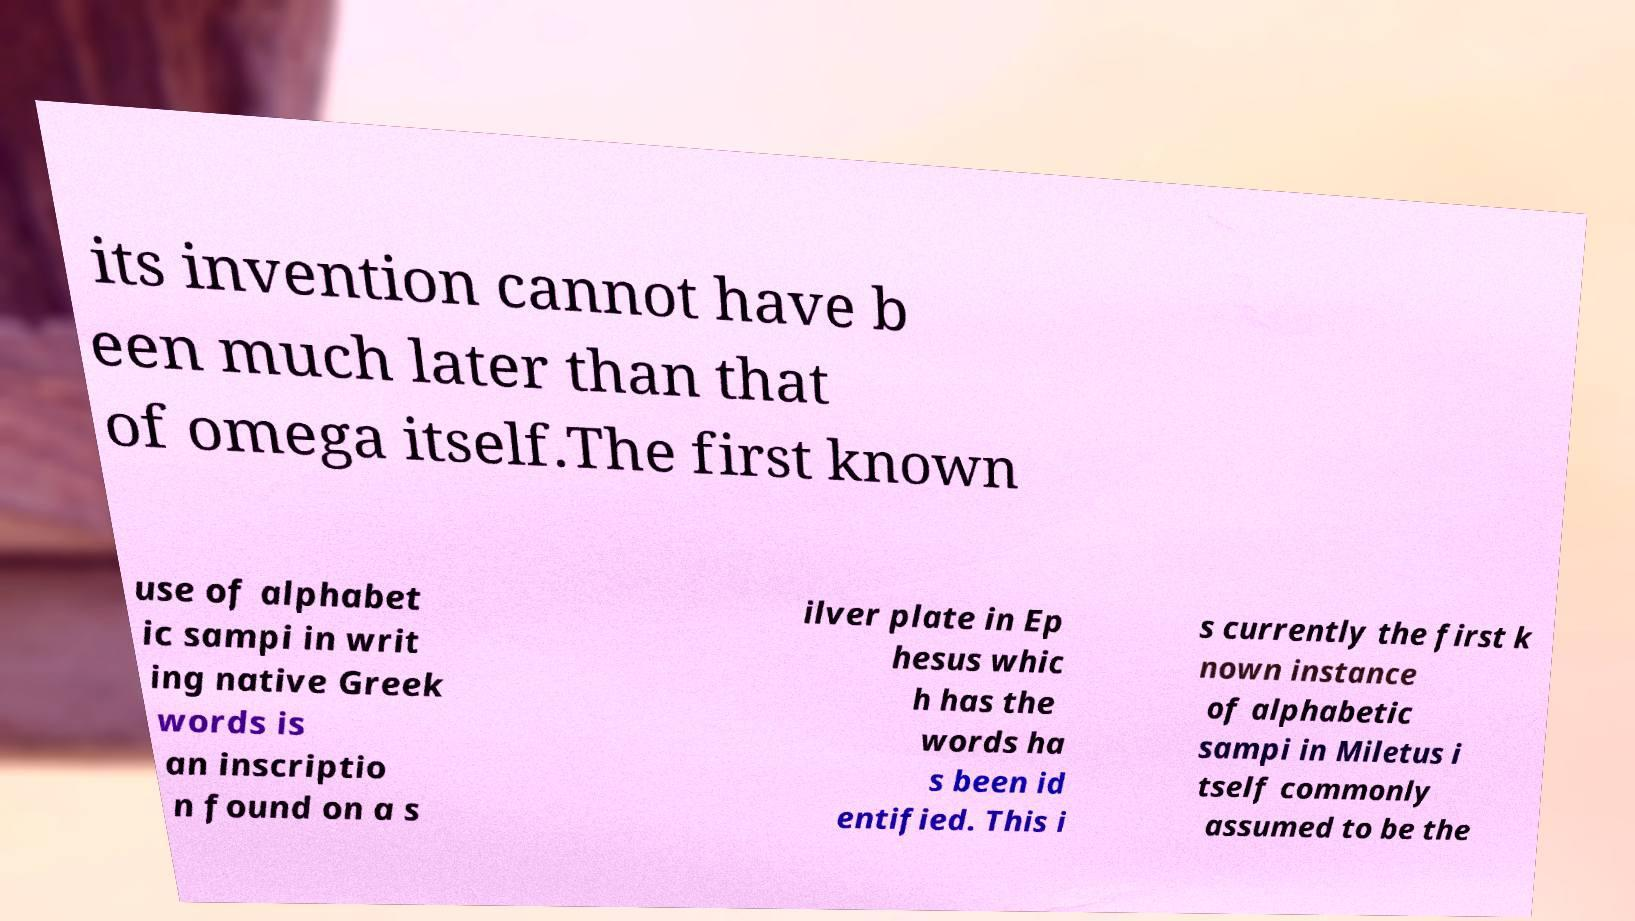Could you extract and type out the text from this image? its invention cannot have b een much later than that of omega itself.The first known use of alphabet ic sampi in writ ing native Greek words is an inscriptio n found on a s ilver plate in Ep hesus whic h has the words ha s been id entified. This i s currently the first k nown instance of alphabetic sampi in Miletus i tself commonly assumed to be the 